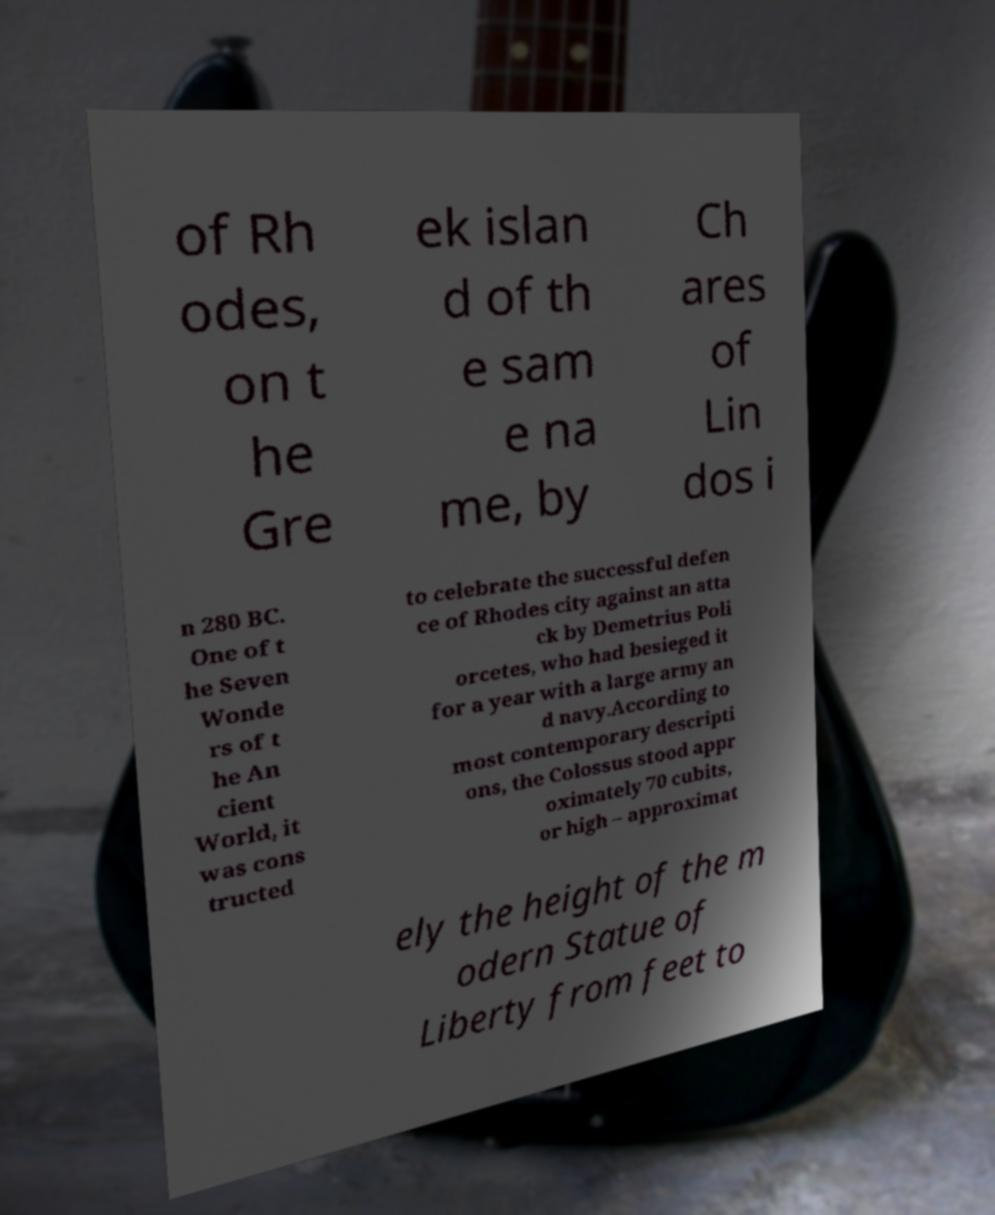Can you accurately transcribe the text from the provided image for me? of Rh odes, on t he Gre ek islan d of th e sam e na me, by Ch ares of Lin dos i n 280 BC. One of t he Seven Wonde rs of t he An cient World, it was cons tructed to celebrate the successful defen ce of Rhodes city against an atta ck by Demetrius Poli orcetes, who had besieged it for a year with a large army an d navy.According to most contemporary descripti ons, the Colossus stood appr oximately 70 cubits, or high – approximat ely the height of the m odern Statue of Liberty from feet to 